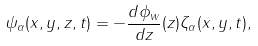Convert formula to latex. <formula><loc_0><loc_0><loc_500><loc_500>\psi _ { \alpha } ( x , y , z , t ) = - \frac { d \phi _ { w } } { d z } ( z ) \zeta _ { \alpha } ( x , y , t ) ,</formula> 